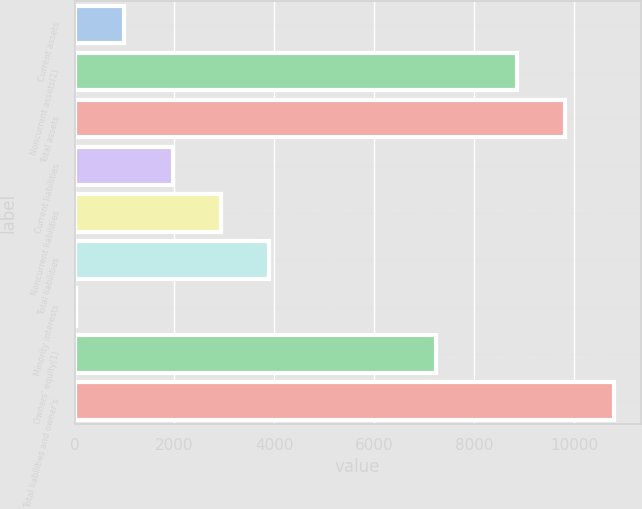Convert chart. <chart><loc_0><loc_0><loc_500><loc_500><bar_chart><fcel>Current assets<fcel>Noncurrent assets(1)<fcel>Total assets<fcel>Current liabilities<fcel>Noncurrent liabilities<fcel>Total liabilities<fcel>Minority interests<fcel>Owners' equity(1)<fcel>Total liabilities and owner's<nl><fcel>996.68<fcel>8853.2<fcel>9820.48<fcel>1963.96<fcel>2931.24<fcel>3898.52<fcel>29.4<fcel>7226.9<fcel>10787.8<nl></chart> 